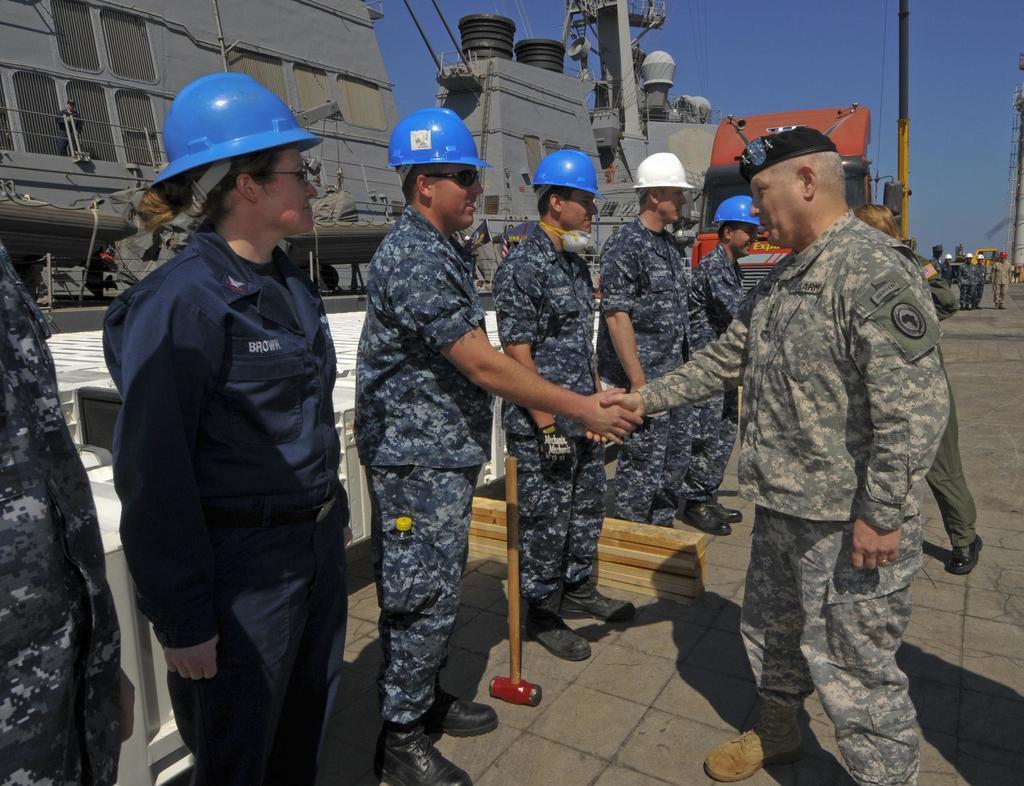How would you summarize this image in a sentence or two? In this image we can see few people. Some are wearing helmets. And one person is wearing cap. In the back we can see containers. Also there is sky. 